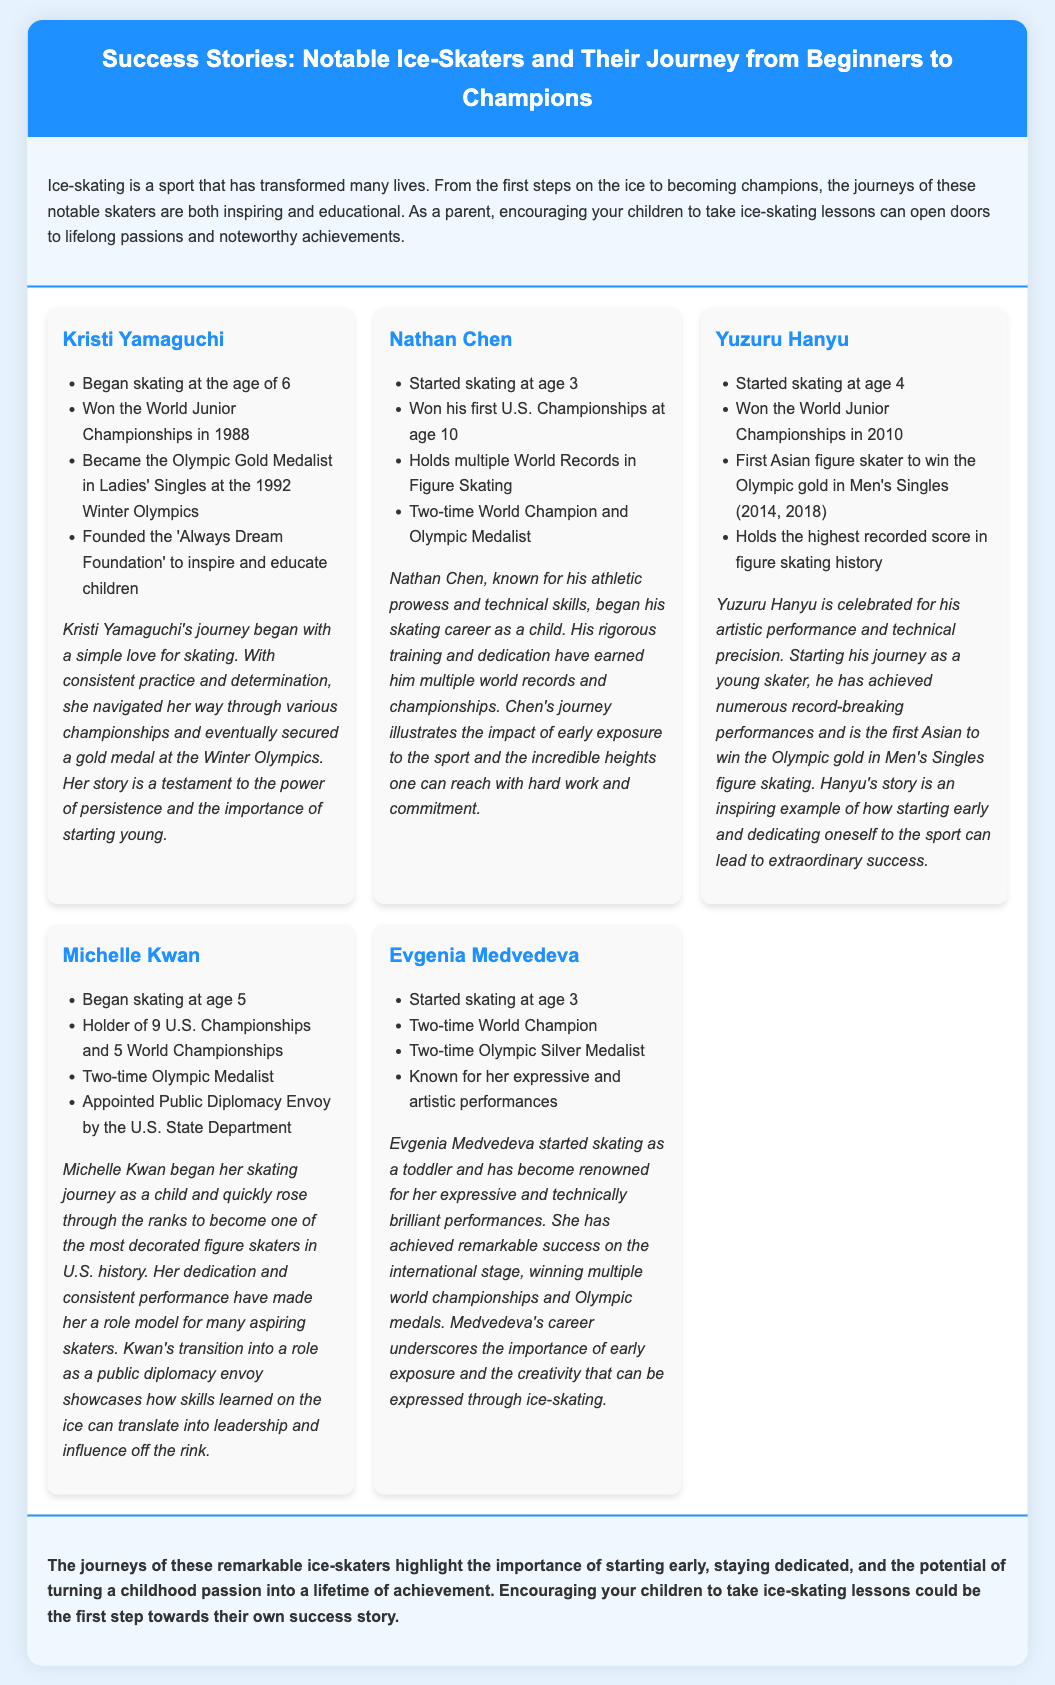what age did Kristi Yamaguchi start skating? Kristi Yamaguchi began skating at the age of 6, as stated in her profile in the document.
Answer: 6 how many World Championships has Michelle Kwan won? Michelle Kwan is the holder of 5 World Championships, which is mentioned in her success story.
Answer: 5 who is the first Asian figure skater to win Olympic gold in Men's Singles? The document states that Yuzuru Hanyu is the first Asian figure skater to achieve this milestone.
Answer: Yuzuru Hanyu what is one foundation founded by Kristi Yamaguchi? Kristi Yamaguchi founded the 'Always Dream Foundation' to inspire and educate children, as noted in her accomplishments.
Answer: Always Dream Foundation how many Olympic medals has Evgenia Medvedeva won? Evgenia Medvedeva has won two Olympic Silver Medals, which is indicated in her profile.
Answer: 2 what is one reason why Nathan Chen's journey is notable? Nathan Chen holds multiple World Records in Figure Skating, showing his remarkable achievements highlighted in the document.
Answer: Multiple World Records which skater emphasized the importance of starting young? The document mentions that Kristi Yamaguchi's journey is a testament to the importance of starting young in ice-skating.
Answer: Kristi Yamaguchi what pattern do the successes of these skaters demonstrate? The document concludes that the journeys of these ice-skaters highlight the importance of starting early and staying dedicated.
Answer: Starting early and staying dedicated 